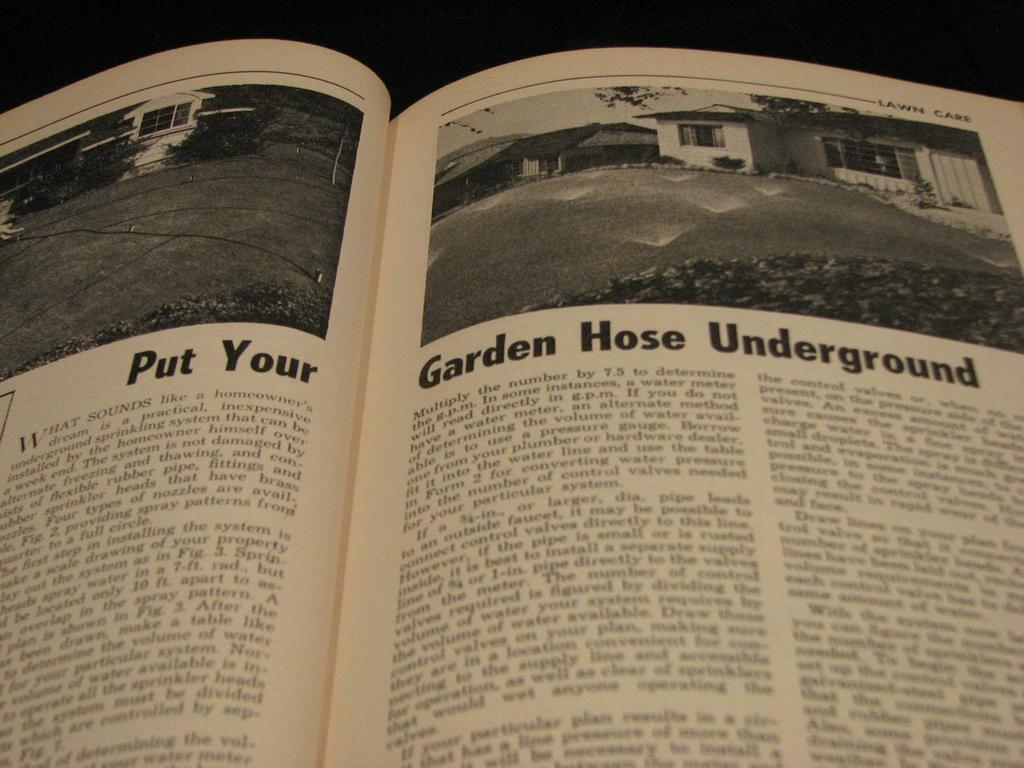<image>
Provide a brief description of the given image. A lawn care book is open to a page advising you to Put Your Garden Hose Underground. 